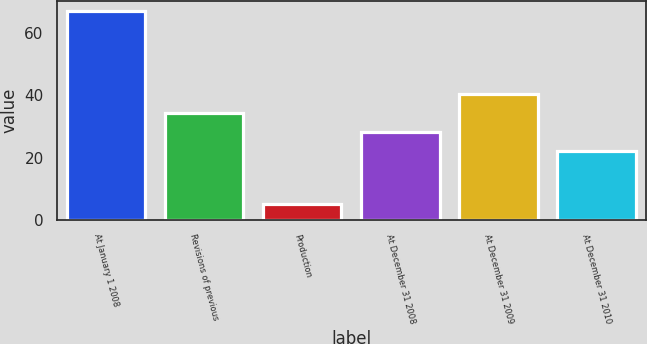<chart> <loc_0><loc_0><loc_500><loc_500><bar_chart><fcel>At January 1 2008<fcel>Revisions of previous<fcel>Production<fcel>At December 31 2008<fcel>At December 31 2009<fcel>At December 31 2010<nl><fcel>67<fcel>34.4<fcel>5<fcel>28.2<fcel>40.6<fcel>22<nl></chart> 